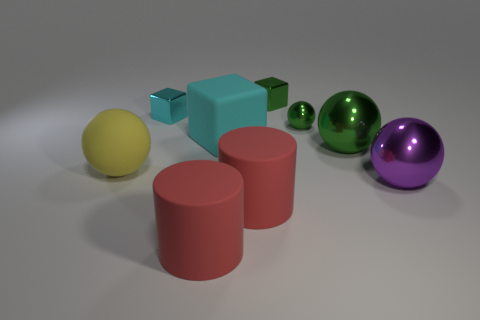Is there anything else that has the same size as the cyan shiny block?
Provide a short and direct response. Yes. Are there any tiny shiny things that have the same color as the big rubber cube?
Give a very brief answer. Yes. Do the small metal cube that is to the left of the green metal cube and the large rubber block have the same color?
Your answer should be very brief. Yes. The small shiny sphere has what color?
Offer a terse response. Green. There is a rubber block that is the same size as the yellow thing; what color is it?
Your answer should be very brief. Cyan. There is a metal object that is in front of the yellow object; is its shape the same as the tiny cyan metal thing?
Give a very brief answer. No. The tiny cube on the left side of the green object that is to the left of the green metal sphere that is behind the big green metal object is what color?
Your answer should be compact. Cyan. Are any blue metal objects visible?
Your answer should be compact. No. What number of other objects are there of the same size as the rubber block?
Give a very brief answer. 5. There is a tiny metal sphere; is it the same color as the tiny cube behind the small cyan metal thing?
Ensure brevity in your answer.  Yes. 